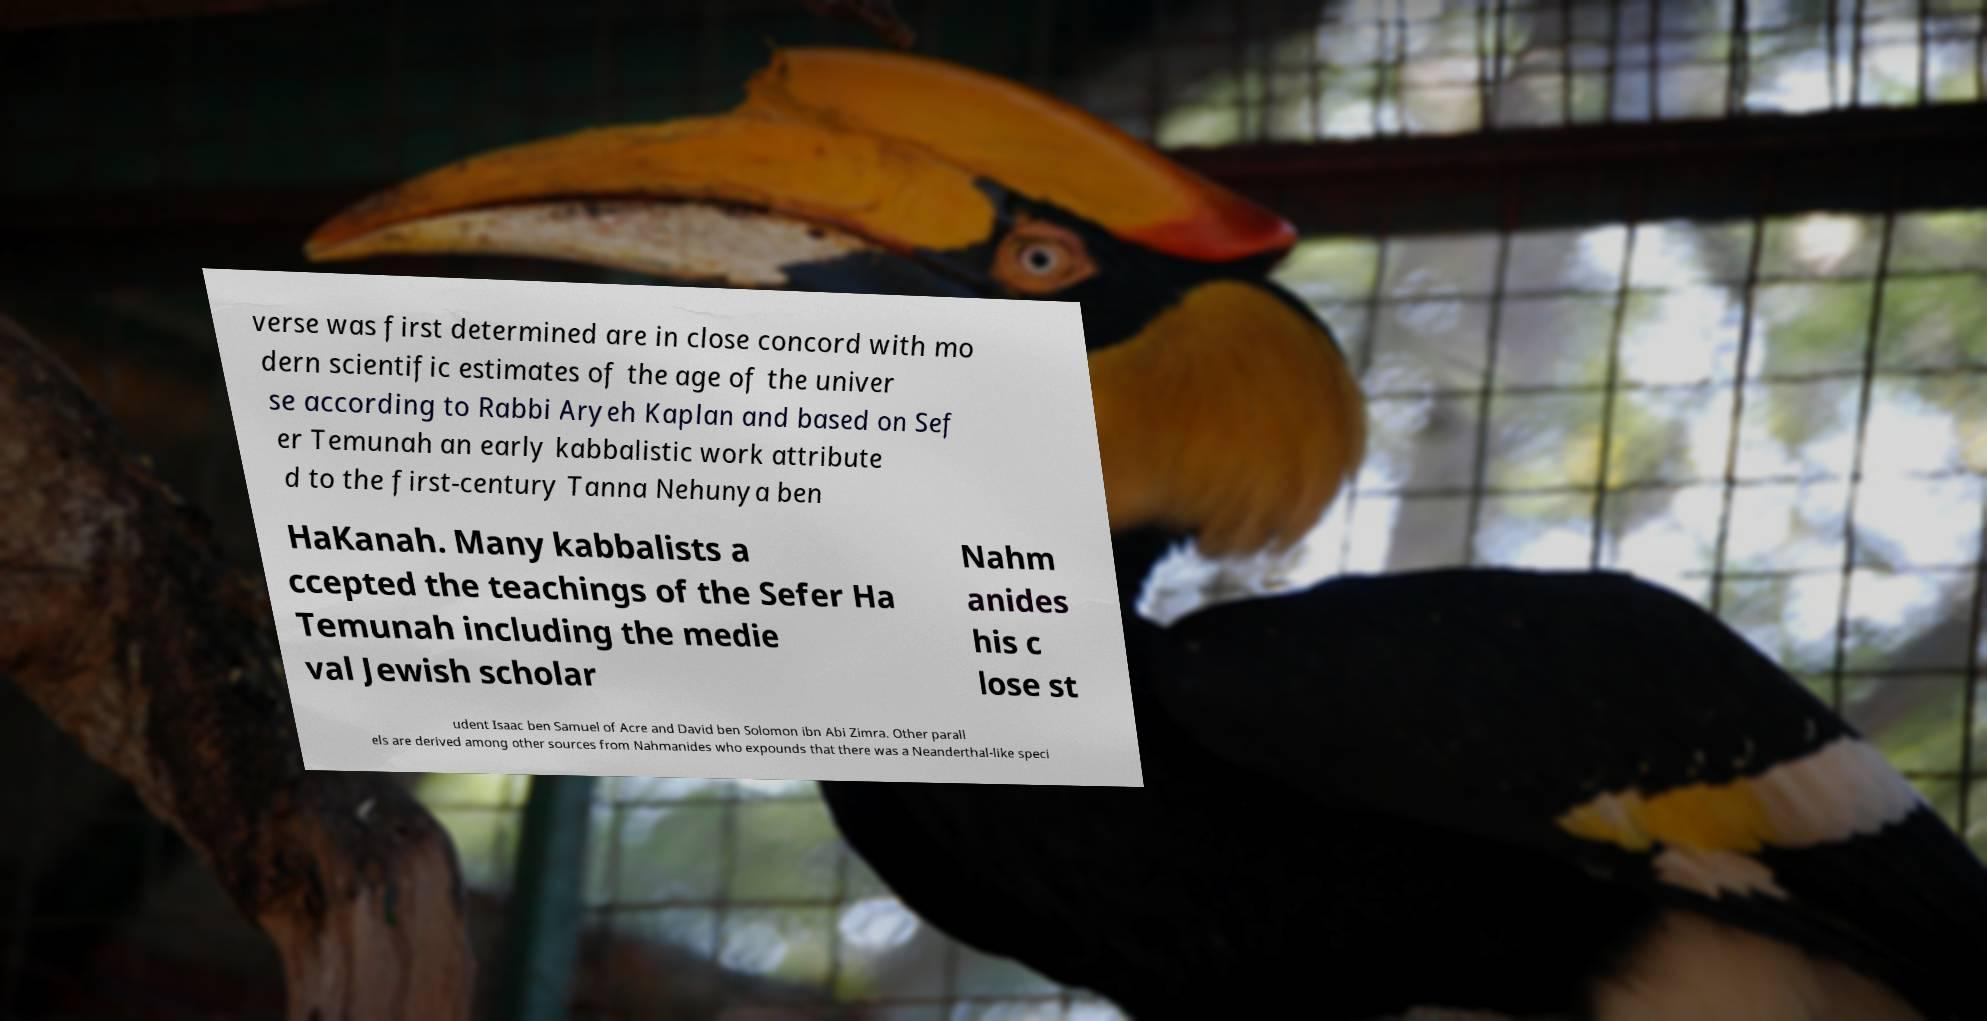I need the written content from this picture converted into text. Can you do that? verse was first determined are in close concord with mo dern scientific estimates of the age of the univer se according to Rabbi Aryeh Kaplan and based on Sef er Temunah an early kabbalistic work attribute d to the first-century Tanna Nehunya ben HaKanah. Many kabbalists a ccepted the teachings of the Sefer Ha Temunah including the medie val Jewish scholar Nahm anides his c lose st udent Isaac ben Samuel of Acre and David ben Solomon ibn Abi Zimra. Other parall els are derived among other sources from Nahmanides who expounds that there was a Neanderthal-like speci 